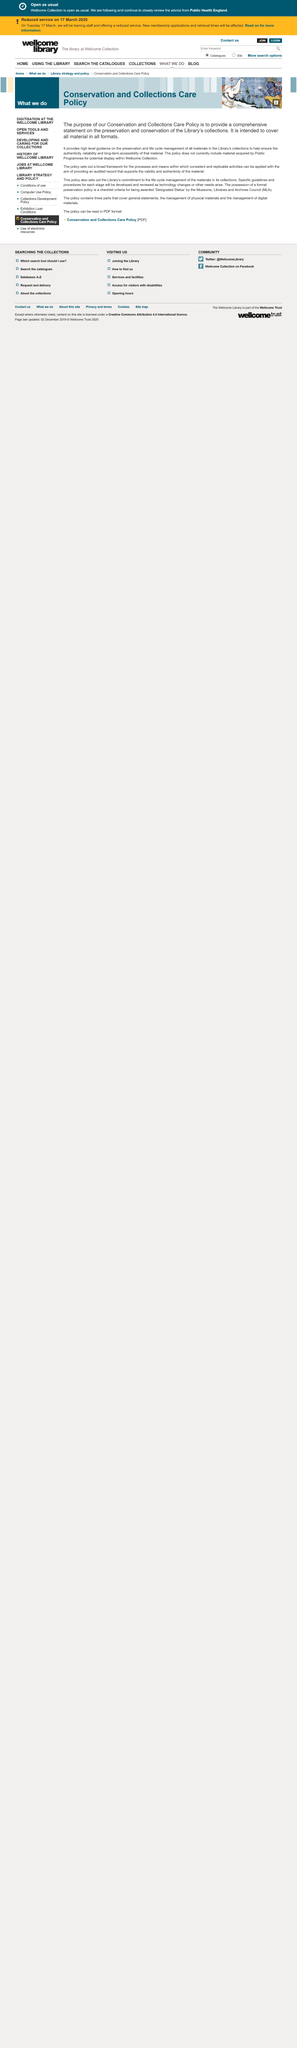Indicate a few pertinent items in this graphic. The Conversation and Collections Care Policy is the name of the library policy. The policy is intended to provide coverage for all materials in all formats. Materials acquired through public programs are not covered under this policy. 